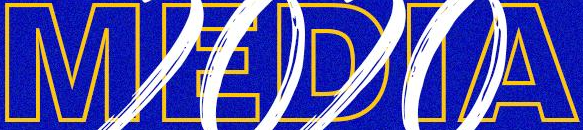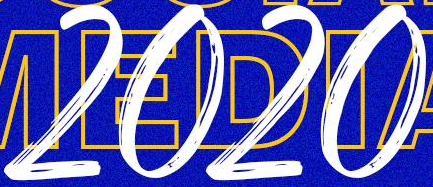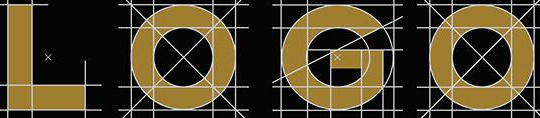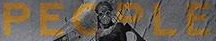Identify the words shown in these images in order, separated by a semicolon. MEDIA; 2020; LOGO; PEOPLE 